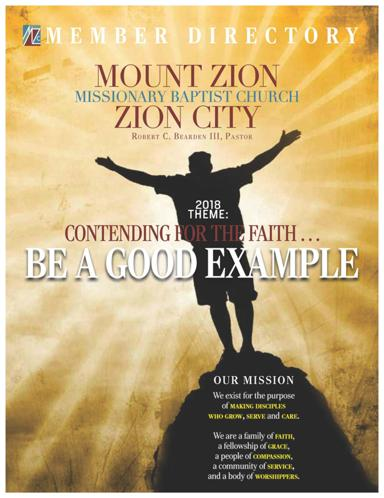Could you tell me more about the design elements used in the church's directory cover? The directory cover utilizes a silhouette of a person with raised hands against a sunset background, symbolizing hope and spirituality. The use of bold, golden text for the church's name adds a visual impact implying a venerable and welcoming atmosphere. 